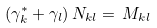<formula> <loc_0><loc_0><loc_500><loc_500>( \gamma _ { k } ^ { * } + \gamma _ { l } ) \, N _ { k l } = \, M _ { k l }</formula> 